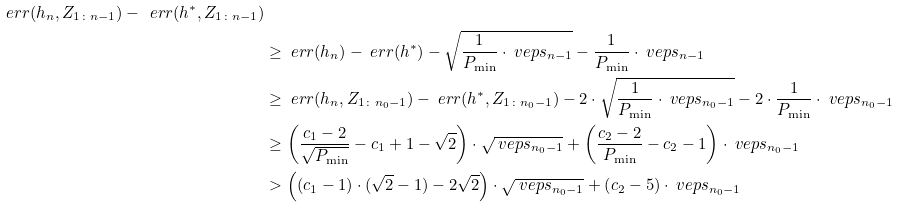<formula> <loc_0><loc_0><loc_500><loc_500>{ \ e r r ( h _ { n } , Z _ { 1 \colon n - 1 } ) - \ e r r ( h ^ { * } , Z _ { 1 \colon n - 1 } ) } \\ & \geq \ e r r ( h _ { n } ) - \ e r r ( h ^ { * } ) - \sqrt { \frac { 1 } { P _ { \min } } \cdot \ v e p s _ { n - 1 } } - \frac { 1 } { P _ { \min } } \cdot \ v e p s _ { n - 1 } \\ & \geq \ e r r ( h _ { n } , Z _ { 1 \colon n _ { 0 } - 1 } ) - \ e r r ( h ^ { * } , Z _ { 1 \colon n _ { 0 } - 1 } ) - 2 \cdot \sqrt { \frac { 1 } { P _ { \min } } \cdot \ v e p s _ { n _ { 0 } - 1 } } - 2 \cdot \frac { 1 } { P _ { \min } } \cdot \ v e p s _ { n _ { 0 } - 1 } \\ & \geq \left ( \frac { c _ { 1 } - 2 } { \sqrt { P _ { \min } } } - c _ { 1 } + 1 - \sqrt { 2 } \right ) \cdot \sqrt { \ v e p s _ { n _ { 0 } - 1 } } + \left ( \frac { c _ { 2 } - 2 } { P _ { \min } } - c _ { 2 } - 1 \right ) \cdot \ v e p s _ { n _ { 0 } - 1 } \\ & > \left ( ( c _ { 1 } - 1 ) \cdot ( \sqrt { 2 } - 1 ) - 2 \sqrt { 2 } \right ) \cdot \sqrt { \ v e p s _ { n _ { 0 } - 1 } } + \left ( c _ { 2 } - 5 \right ) \cdot \ v e p s _ { n _ { 0 } - 1 }</formula> 